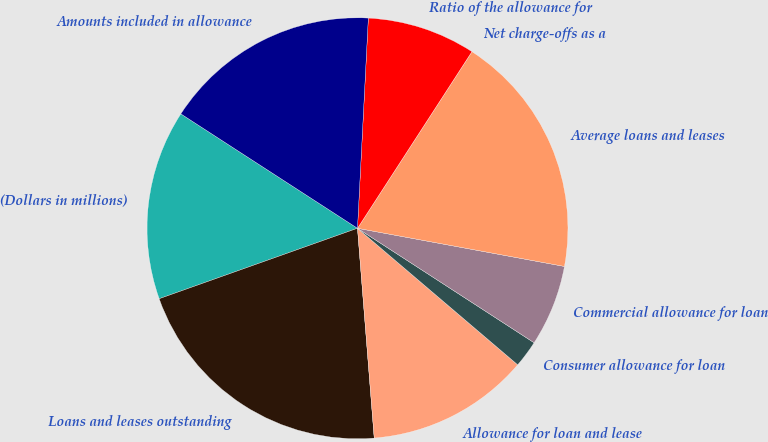Convert chart. <chart><loc_0><loc_0><loc_500><loc_500><pie_chart><fcel>(Dollars in millions)<fcel>Loans and leases outstanding<fcel>Allowance for loan and lease<fcel>Consumer allowance for loan<fcel>Commercial allowance for loan<fcel>Average loans and leases<fcel>Net charge-offs as a<fcel>Ratio of the allowance for<fcel>Amounts included in allowance<nl><fcel>14.58%<fcel>20.83%<fcel>12.5%<fcel>2.08%<fcel>6.25%<fcel>18.75%<fcel>0.0%<fcel>8.33%<fcel>16.67%<nl></chart> 